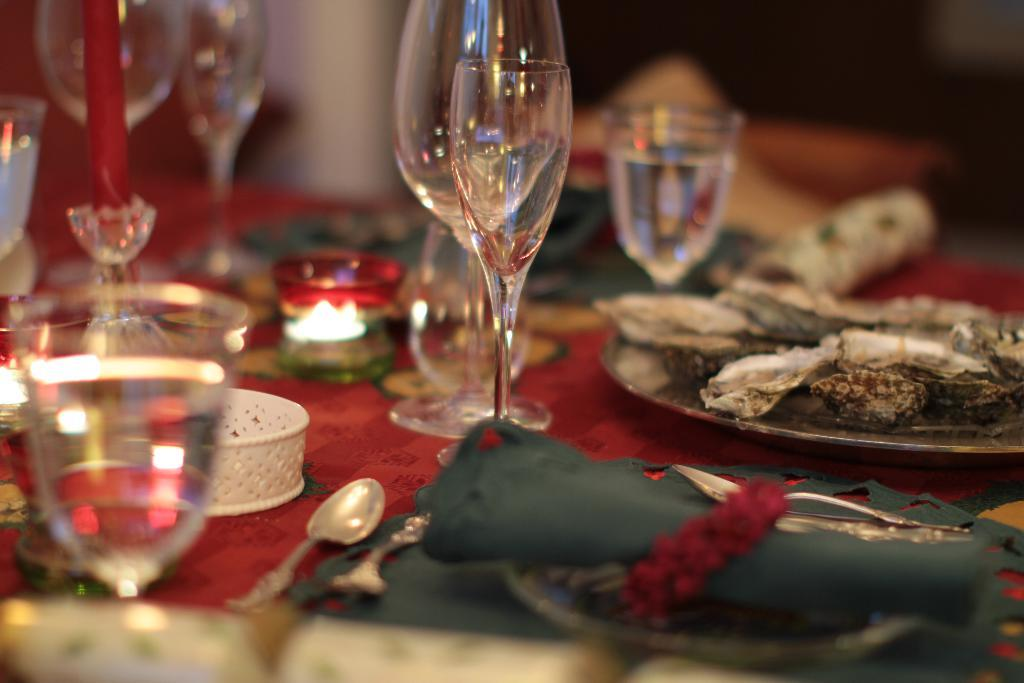What piece of furniture is present in the image? There is a table in the picture. What items can be seen on the table? There are glasses, plates, spoons, knives, and candles on the table. How many different types of utensils are on the table? There are three types of utensils on the table: spoons, knives, and forks. Can you tell me how many keys are on the table in the image? There are no keys present on the table in the image. What type of snake can be seen slithering across the table in the image? There are no snakes present on the table in the image. 